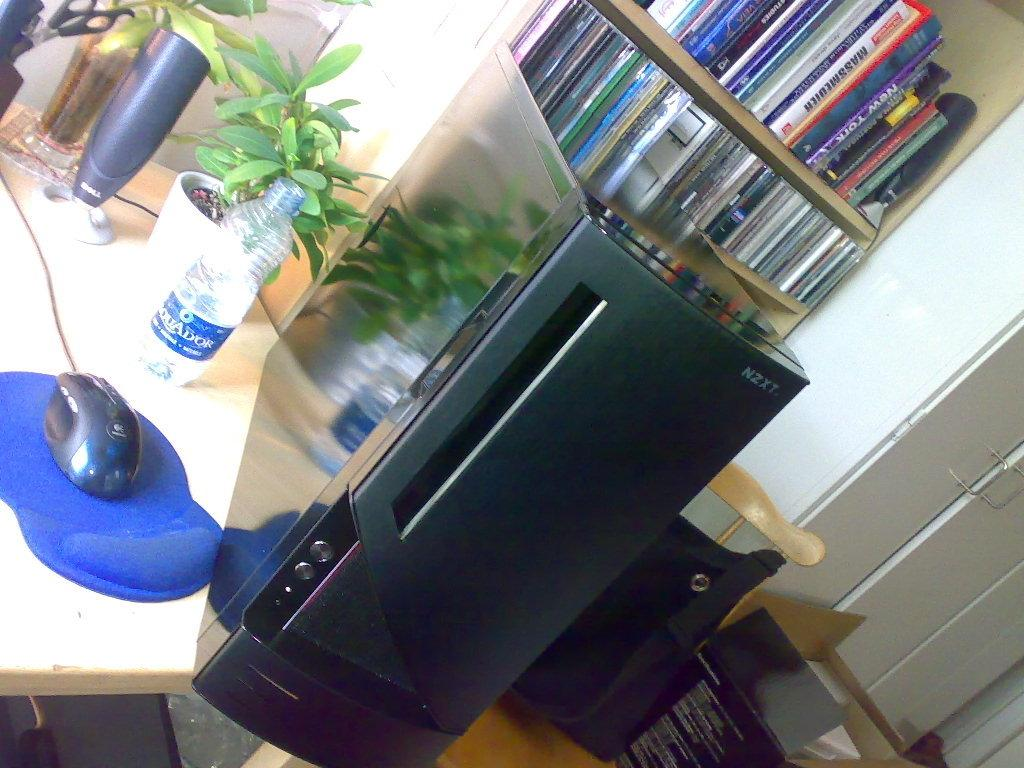What type of CPU is visible in the image? There is a black CPU in the image. Where is the CPU located? The CPU is placed on a table. What other computer-related item can be seen in the image? There is a mouse (likely a computer mouse) in the image. What type of object is present that is not related to computers? There is a plant pot in the image. What can be seen that might be used for learning or reference? There is a rack full of books in the image. What type of insurance policy is being discussed in the image? There is no mention of insurance in the image; it primarily features a black CPU, a computer mouse, a plant pot, and a rack full of books. 